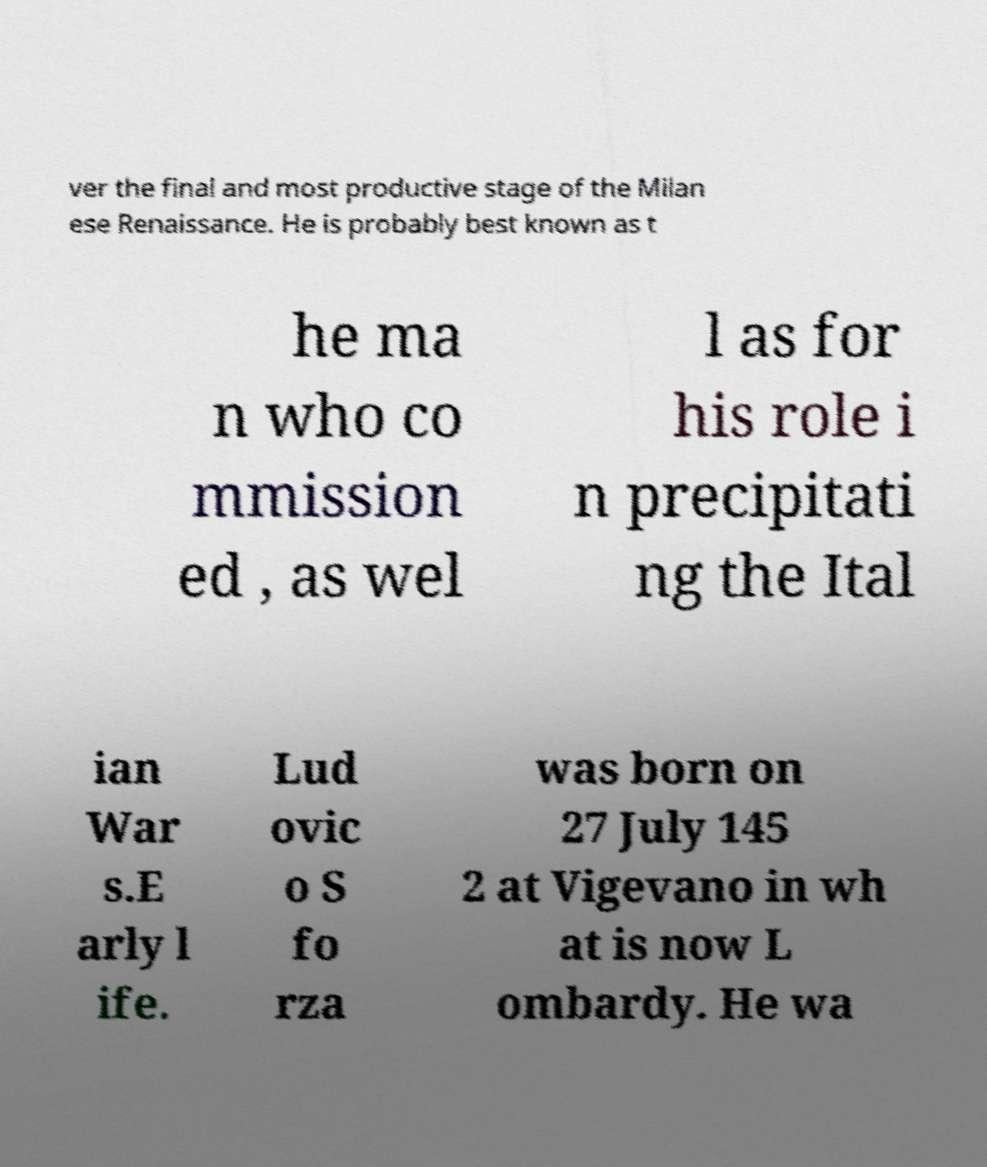Could you extract and type out the text from this image? ver the final and most productive stage of the Milan ese Renaissance. He is probably best known as t he ma n who co mmission ed , as wel l as for his role i n precipitati ng the Ital ian War s.E arly l ife. Lud ovic o S fo rza was born on 27 July 145 2 at Vigevano in wh at is now L ombardy. He wa 